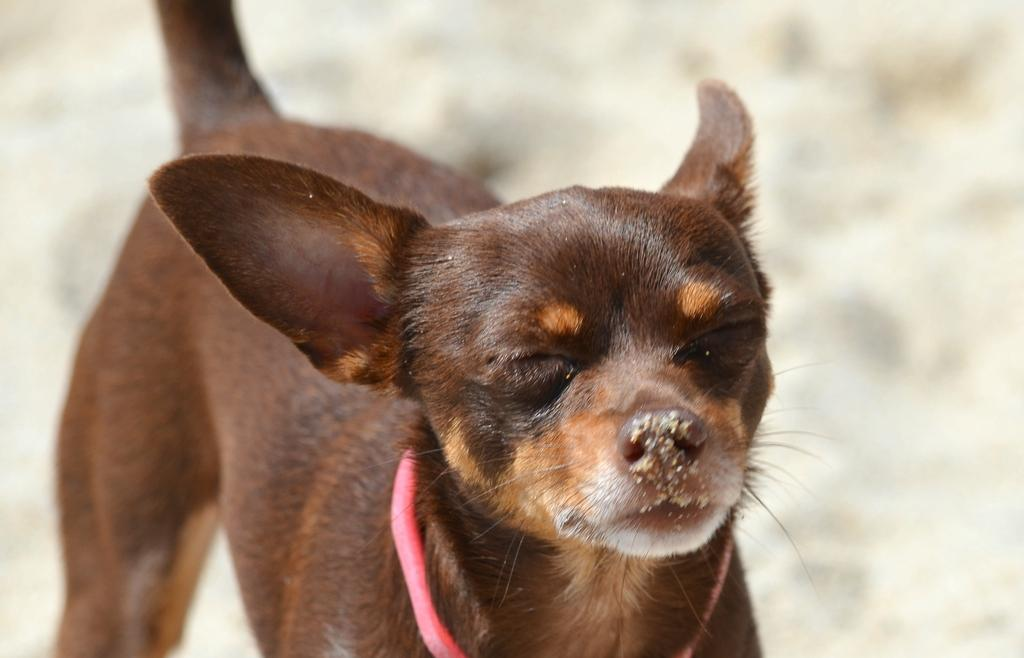What animal can be seen in the image? There is a dog in the image. What is the dog doing in the image? The dog is standing on the ground. Is there any accessory on the dog? Yes, there is a belt around the dog's neck. What is on the dog's nose? There is sand on the dog's nose. How would you describe the background behind the dog? The area behind the dog is blurry. Can you see a kettle in the image? No, there is no kettle present in the image. Is the dog wearing a hat in the image? No, the dog is not wearing a hat in the image. 